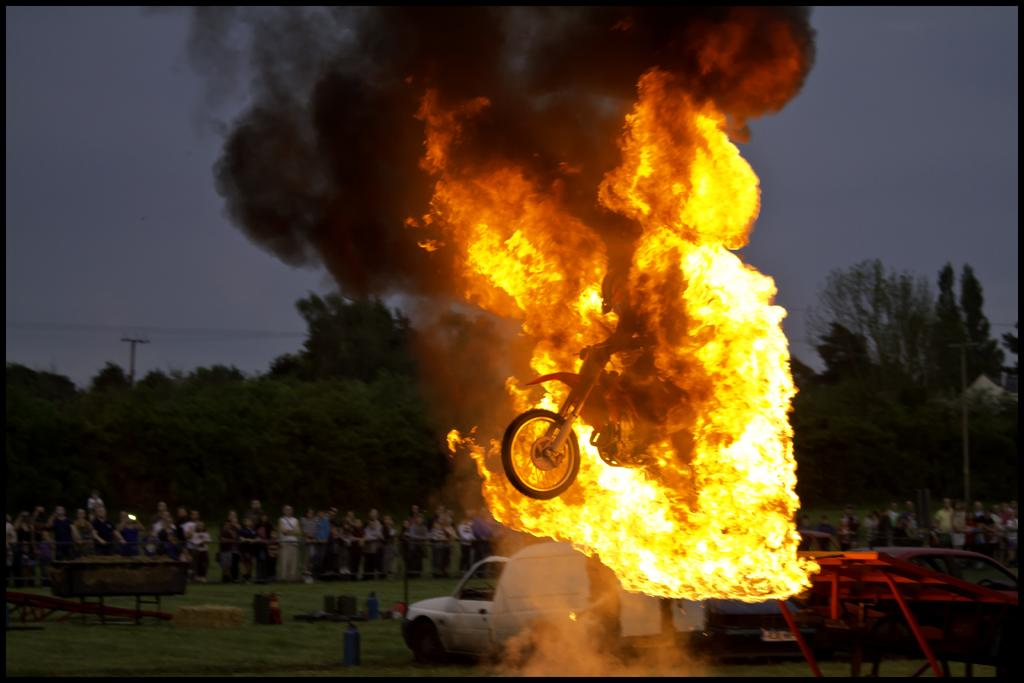What is the primary element in the image that is causing the smoke? There is fire in the image, which is causing the smoke. What type of vehicle can be seen in the image? There are vehicles in the image, but the specific type is not mentioned. What is the natural environment visible in the image? There is grass and trees visible in the background of the image. What is the condition of the sky in the image? The sky is visible in the background of the image, but its condition is not specified. How many people are standing on the ground in the image? There are people standing on the ground in the image, but the exact number is not mentioned. What class of passenger is allowed to ride the bike in the image? There is no mention of passengers or classes in the image; it only shows a bike. What type of wrench is being used to fix the fire in the image in the image? There is no wrench present in the image, and the fire is not being fixed; it is causing the smoke. 